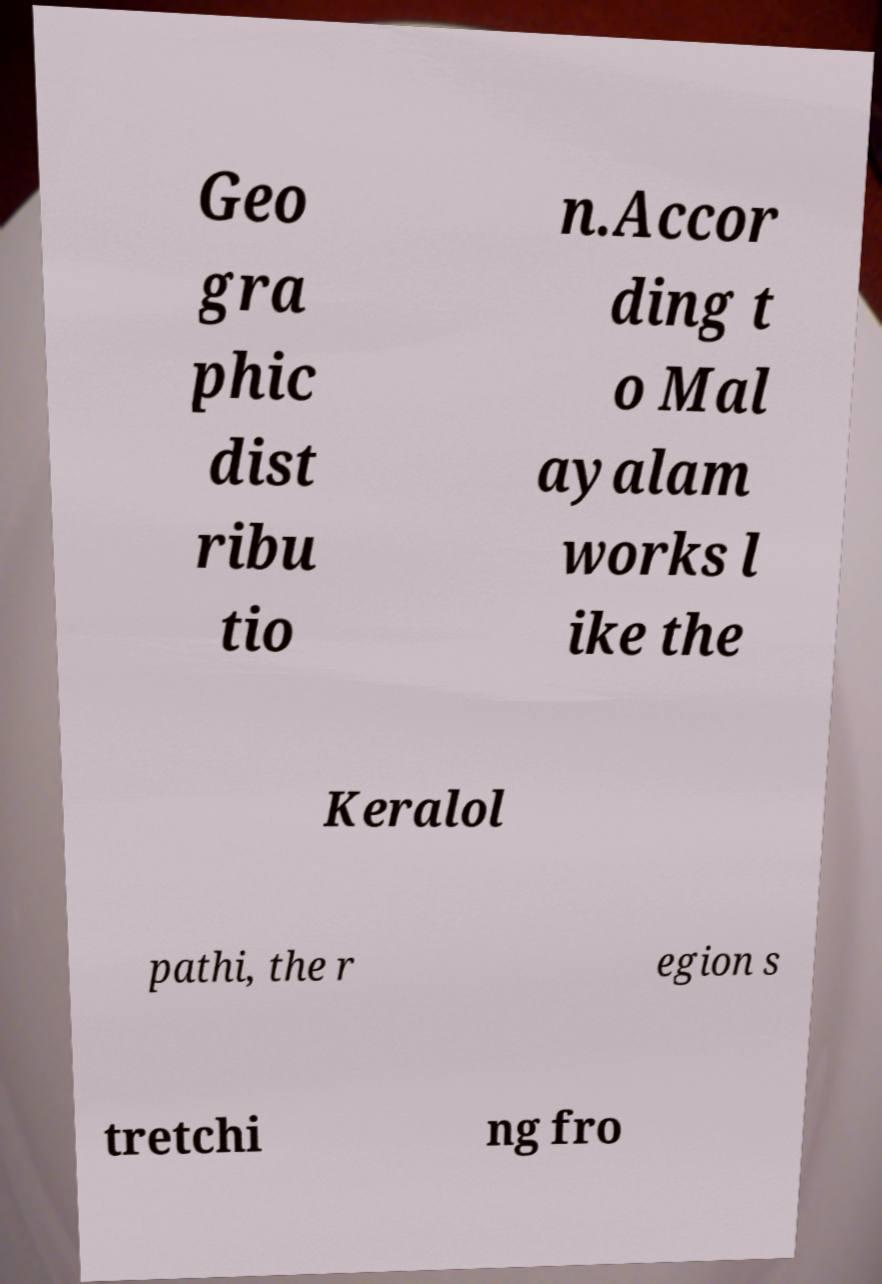Could you extract and type out the text from this image? Geo gra phic dist ribu tio n.Accor ding t o Mal ayalam works l ike the Keralol pathi, the r egion s tretchi ng fro 